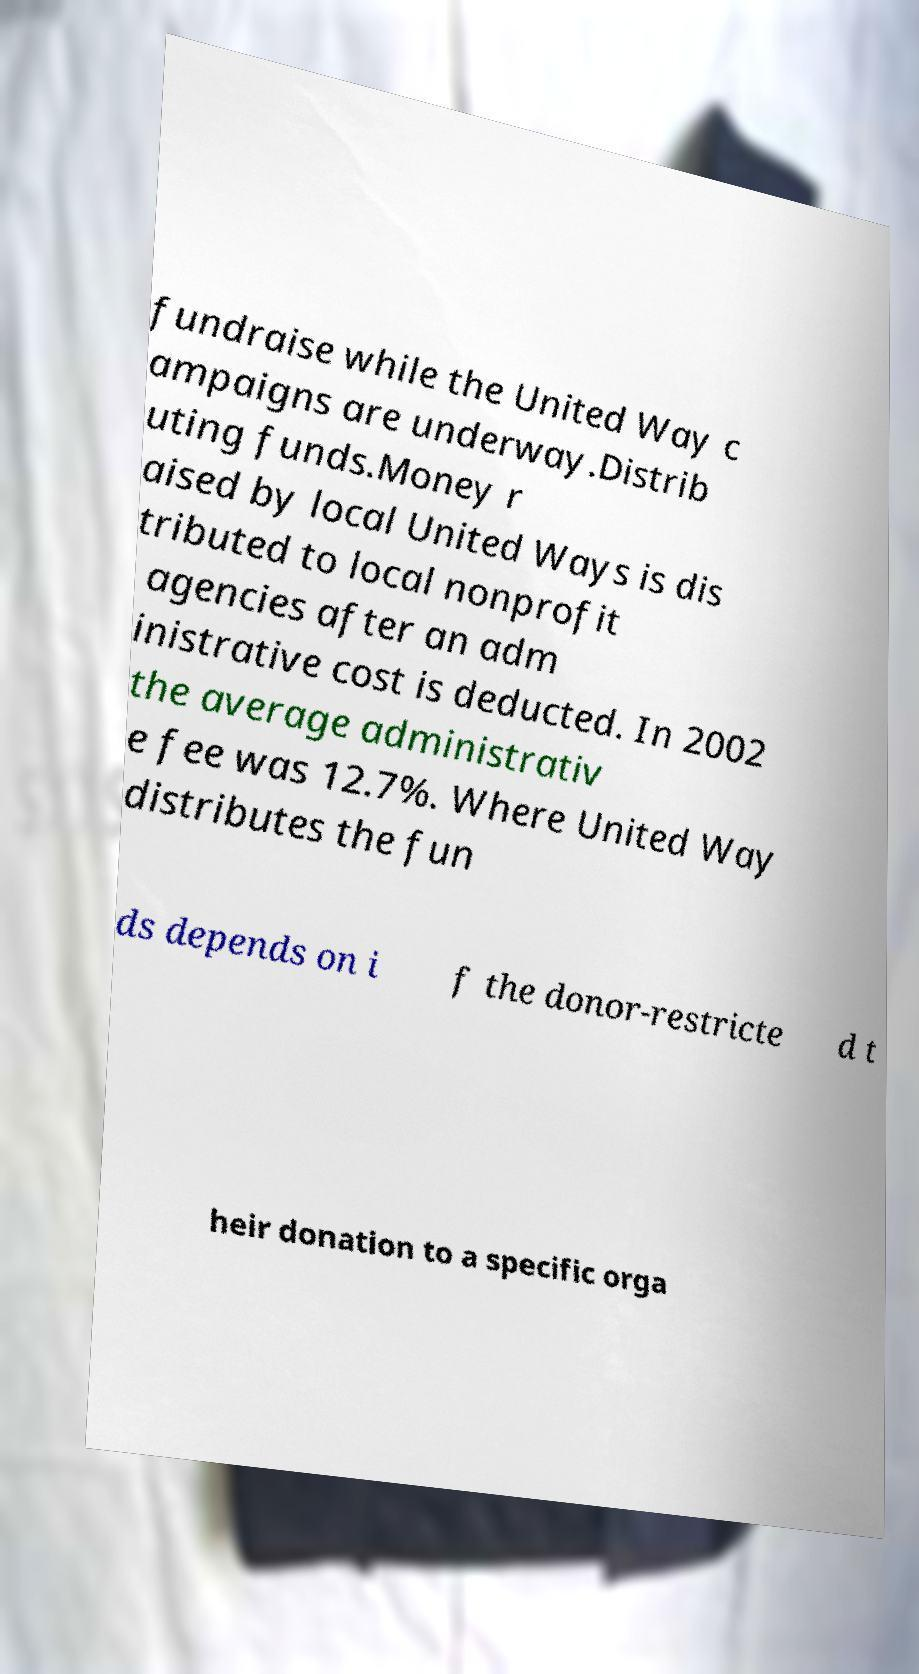I need the written content from this picture converted into text. Can you do that? fundraise while the United Way c ampaigns are underway.Distrib uting funds.Money r aised by local United Ways is dis tributed to local nonprofit agencies after an adm inistrative cost is deducted. In 2002 the average administrativ e fee was 12.7%. Where United Way distributes the fun ds depends on i f the donor-restricte d t heir donation to a specific orga 